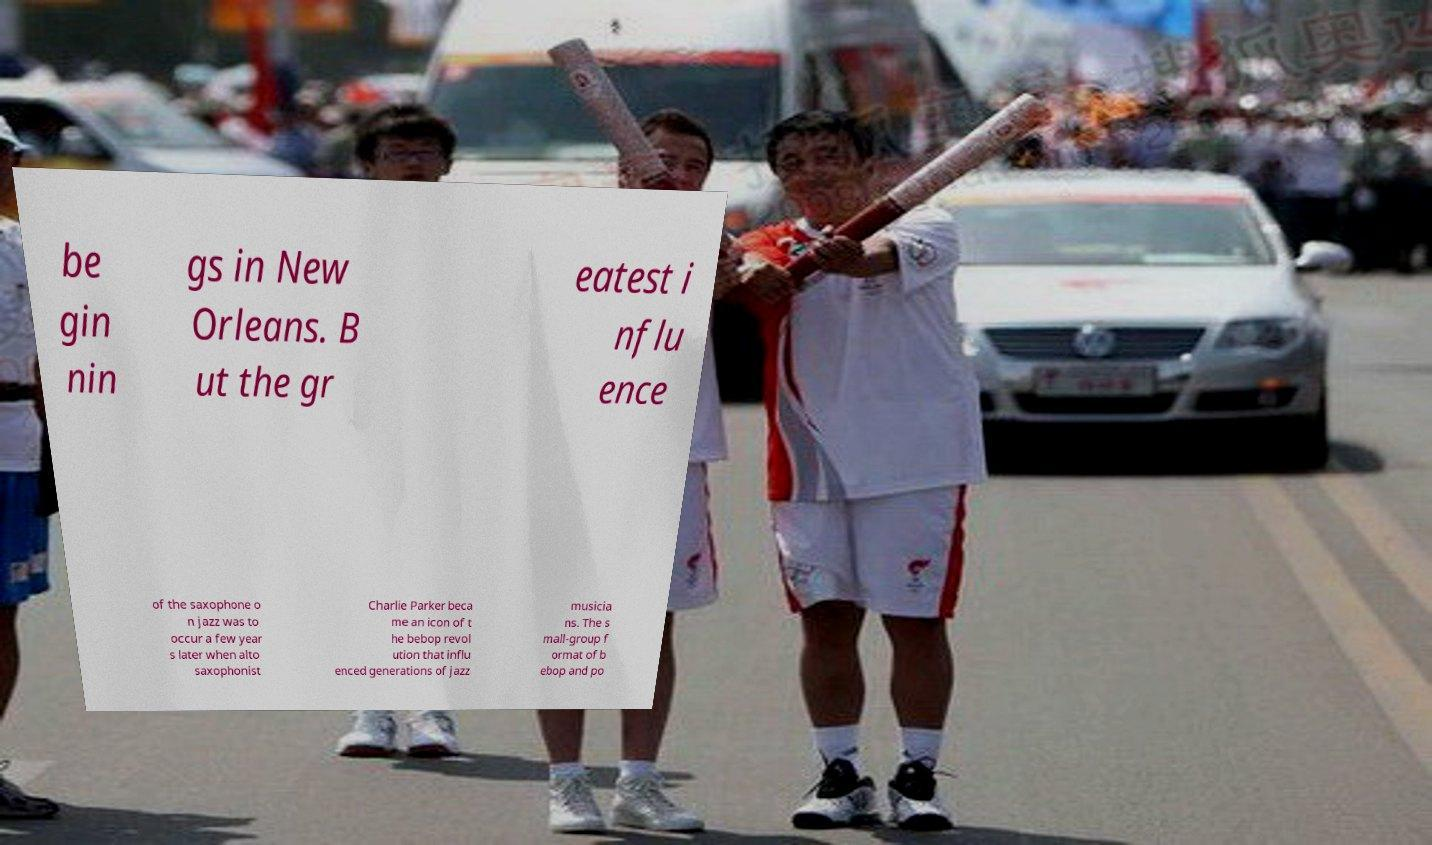Please identify and transcribe the text found in this image. be gin nin gs in New Orleans. B ut the gr eatest i nflu ence of the saxophone o n jazz was to occur a few year s later when alto saxophonist Charlie Parker beca me an icon of t he bebop revol ution that influ enced generations of jazz musicia ns. The s mall-group f ormat of b ebop and po 